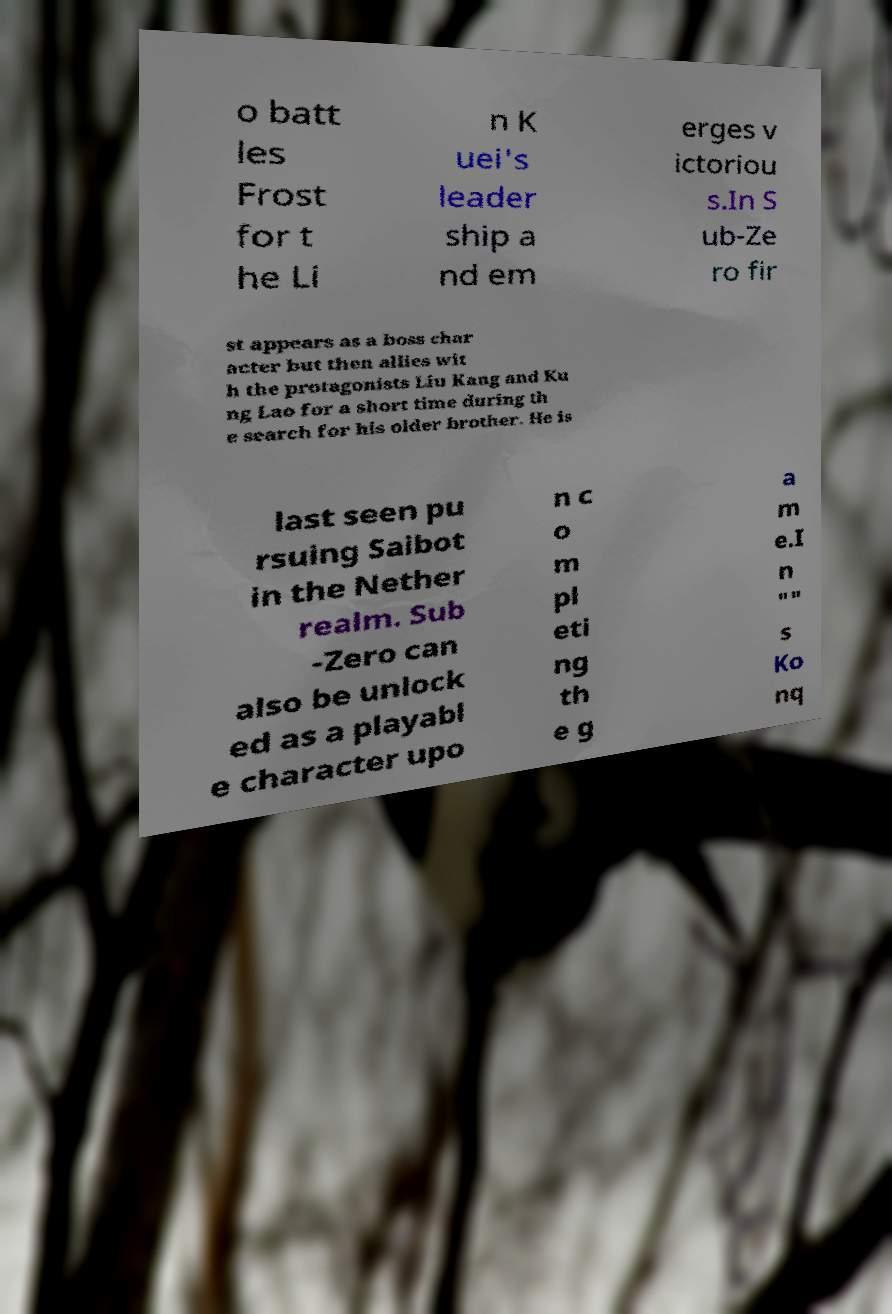Could you assist in decoding the text presented in this image and type it out clearly? o batt les Frost for t he Li n K uei's leader ship a nd em erges v ictoriou s.In S ub-Ze ro fir st appears as a boss char acter but then allies wit h the protagonists Liu Kang and Ku ng Lao for a short time during th e search for his older brother. He is last seen pu rsuing Saibot in the Nether realm. Sub -Zero can also be unlock ed as a playabl e character upo n c o m pl eti ng th e g a m e.I n "" s Ko nq 